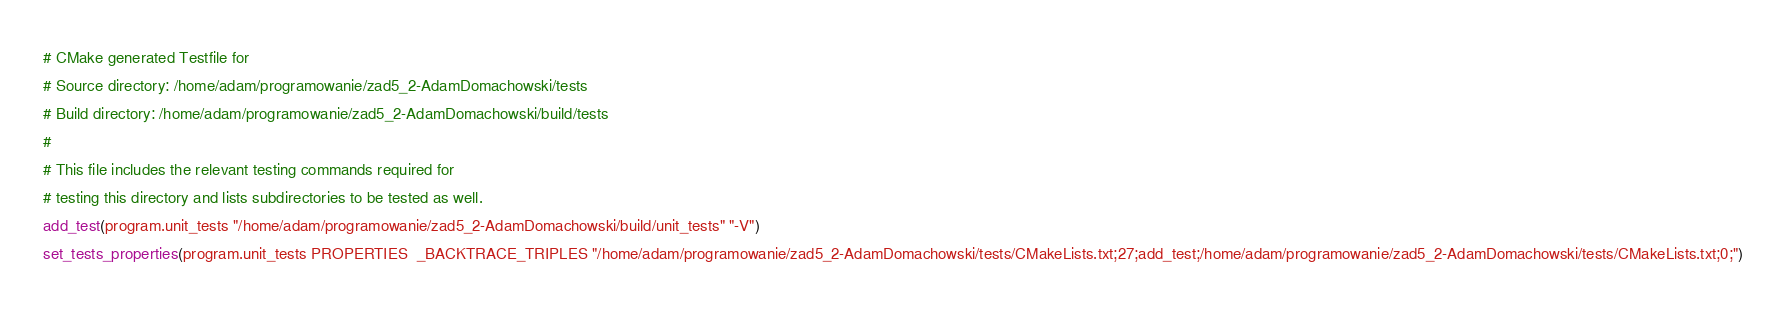<code> <loc_0><loc_0><loc_500><loc_500><_CMake_># CMake generated Testfile for 
# Source directory: /home/adam/programowanie/zad5_2-AdamDomachowski/tests
# Build directory: /home/adam/programowanie/zad5_2-AdamDomachowski/build/tests
# 
# This file includes the relevant testing commands required for 
# testing this directory and lists subdirectories to be tested as well.
add_test(program.unit_tests "/home/adam/programowanie/zad5_2-AdamDomachowski/build/unit_tests" "-V")
set_tests_properties(program.unit_tests PROPERTIES  _BACKTRACE_TRIPLES "/home/adam/programowanie/zad5_2-AdamDomachowski/tests/CMakeLists.txt;27;add_test;/home/adam/programowanie/zad5_2-AdamDomachowski/tests/CMakeLists.txt;0;")
</code> 